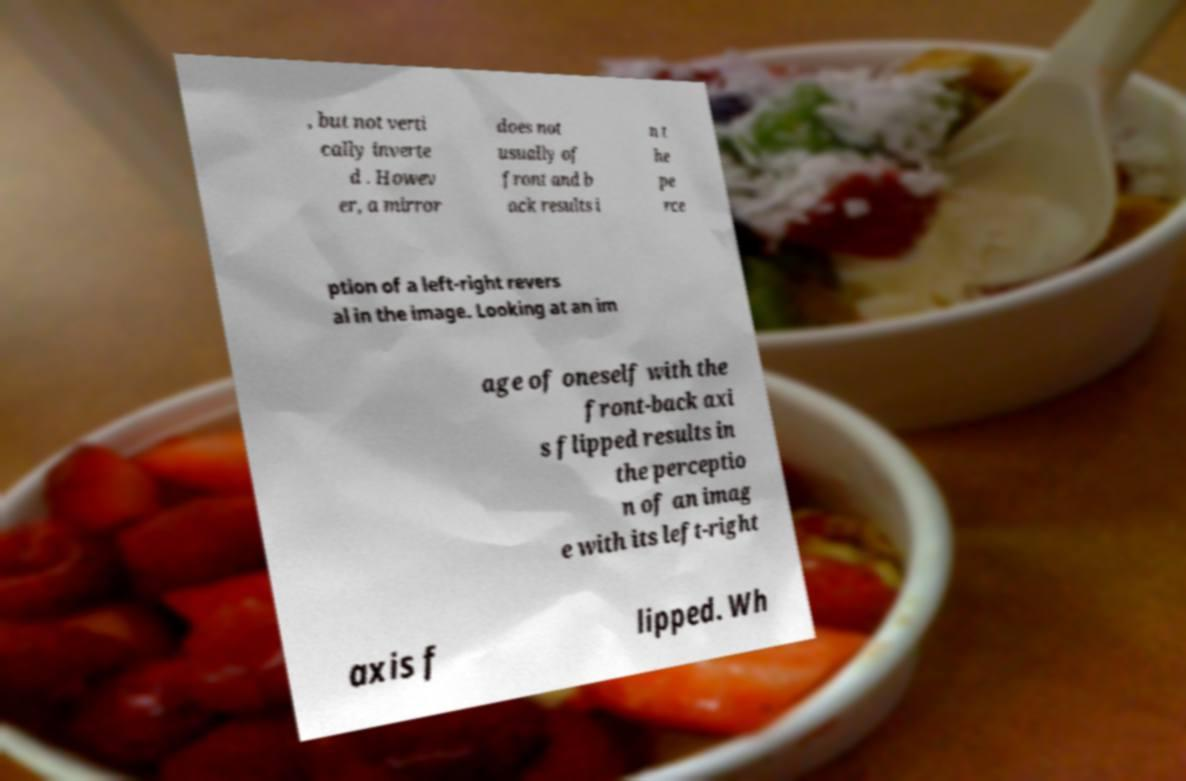Please identify and transcribe the text found in this image. , but not verti cally inverte d . Howev er, a mirror does not usually of front and b ack results i n t he pe rce ption of a left-right revers al in the image. Looking at an im age of oneself with the front-back axi s flipped results in the perceptio n of an imag e with its left-right axis f lipped. Wh 